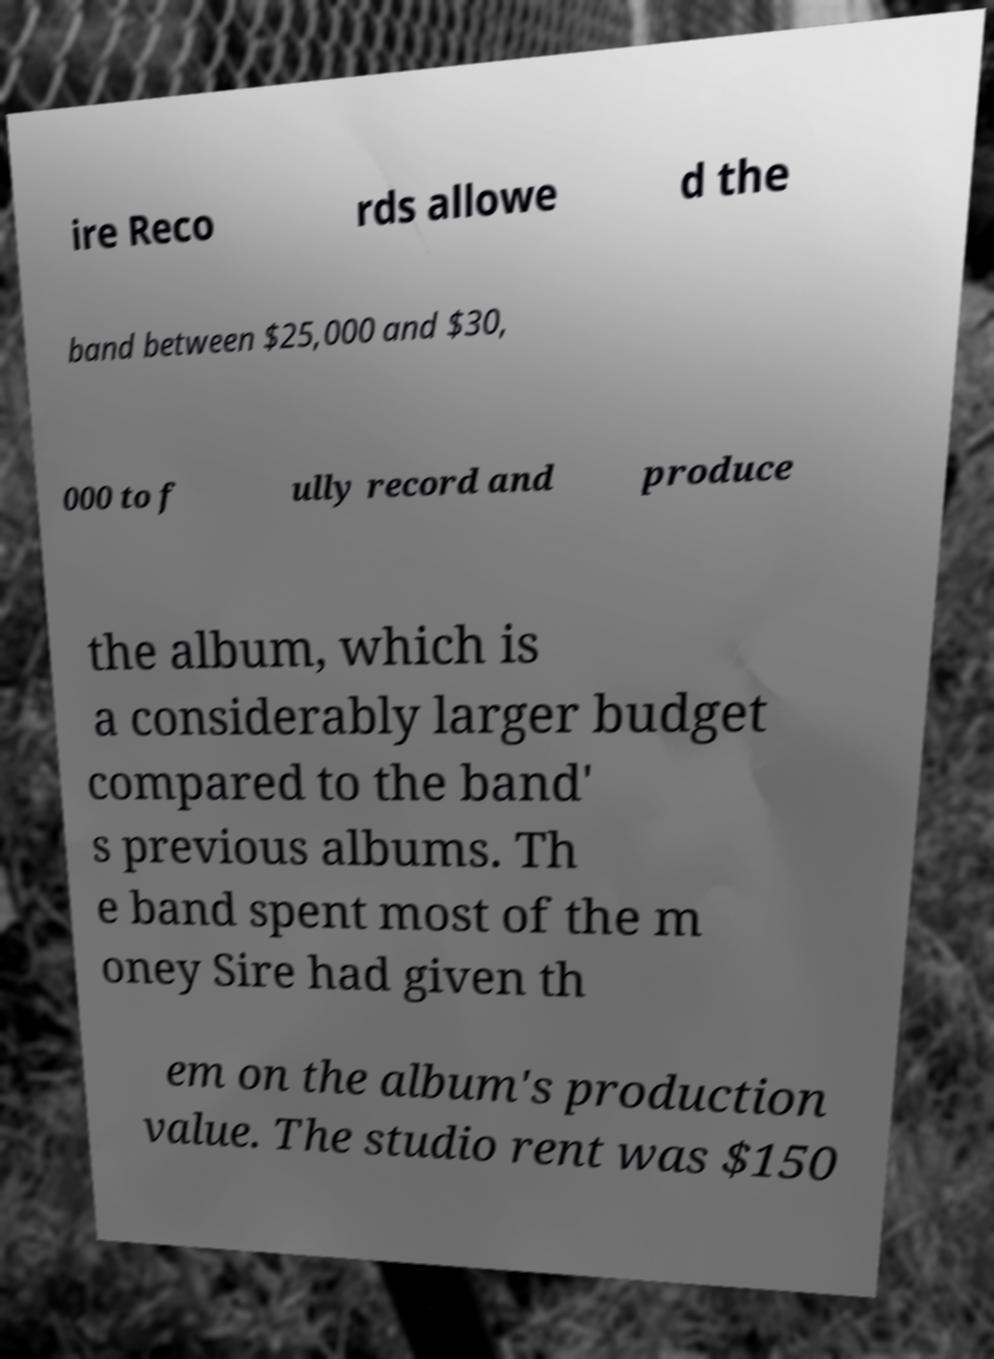Please identify and transcribe the text found in this image. ire Reco rds allowe d the band between $25,000 and $30, 000 to f ully record and produce the album, which is a considerably larger budget compared to the band' s previous albums. Th e band spent most of the m oney Sire had given th em on the album's production value. The studio rent was $150 